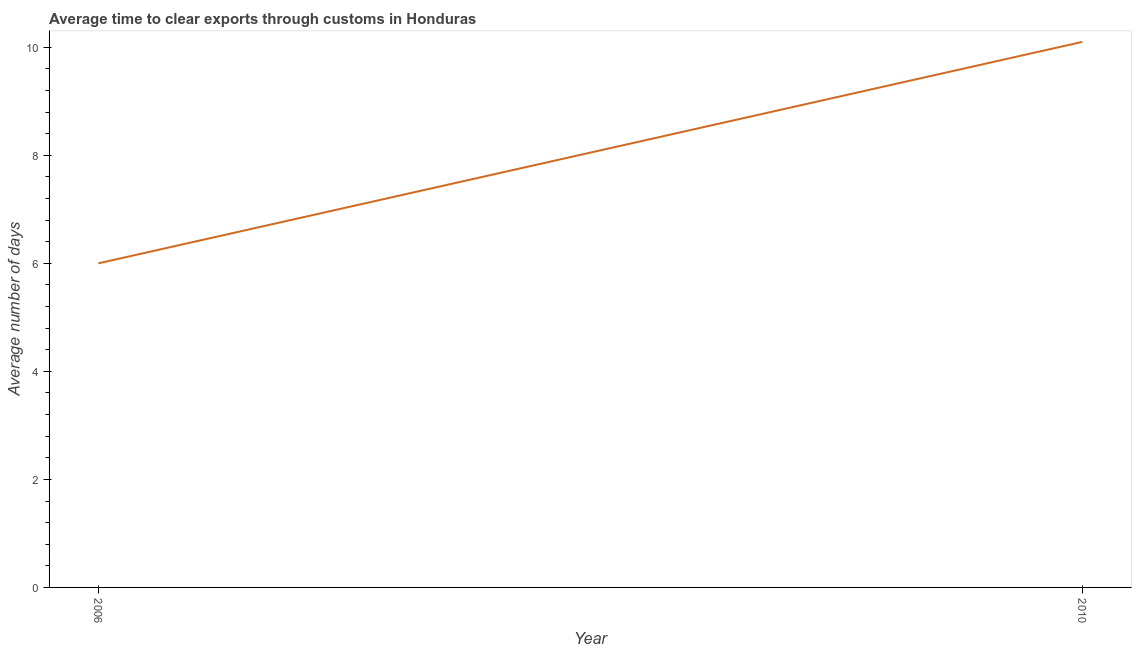What is the time to clear exports through customs in 2010?
Your answer should be very brief. 10.1. Across all years, what is the maximum time to clear exports through customs?
Ensure brevity in your answer.  10.1. In which year was the time to clear exports through customs maximum?
Provide a short and direct response. 2010. What is the sum of the time to clear exports through customs?
Keep it short and to the point. 16.1. What is the difference between the time to clear exports through customs in 2006 and 2010?
Your answer should be very brief. -4.1. What is the average time to clear exports through customs per year?
Make the answer very short. 8.05. What is the median time to clear exports through customs?
Provide a succinct answer. 8.05. In how many years, is the time to clear exports through customs greater than 4.8 days?
Ensure brevity in your answer.  2. What is the ratio of the time to clear exports through customs in 2006 to that in 2010?
Provide a succinct answer. 0.59. Does the time to clear exports through customs monotonically increase over the years?
Provide a succinct answer. Yes. How many lines are there?
Ensure brevity in your answer.  1. How many years are there in the graph?
Offer a very short reply. 2. What is the difference between two consecutive major ticks on the Y-axis?
Offer a very short reply. 2. Does the graph contain any zero values?
Your response must be concise. No. What is the title of the graph?
Give a very brief answer. Average time to clear exports through customs in Honduras. What is the label or title of the Y-axis?
Make the answer very short. Average number of days. What is the difference between the Average number of days in 2006 and 2010?
Your answer should be compact. -4.1. What is the ratio of the Average number of days in 2006 to that in 2010?
Ensure brevity in your answer.  0.59. 